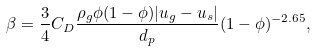Convert formula to latex. <formula><loc_0><loc_0><loc_500><loc_500>\beta = \frac { 3 } { 4 } C _ { D } \frac { \rho _ { g } \phi ( 1 - \phi ) | u _ { g } - u _ { s } | } { d _ { p } } ( 1 - \phi ) ^ { - 2 . 6 5 } ,</formula> 